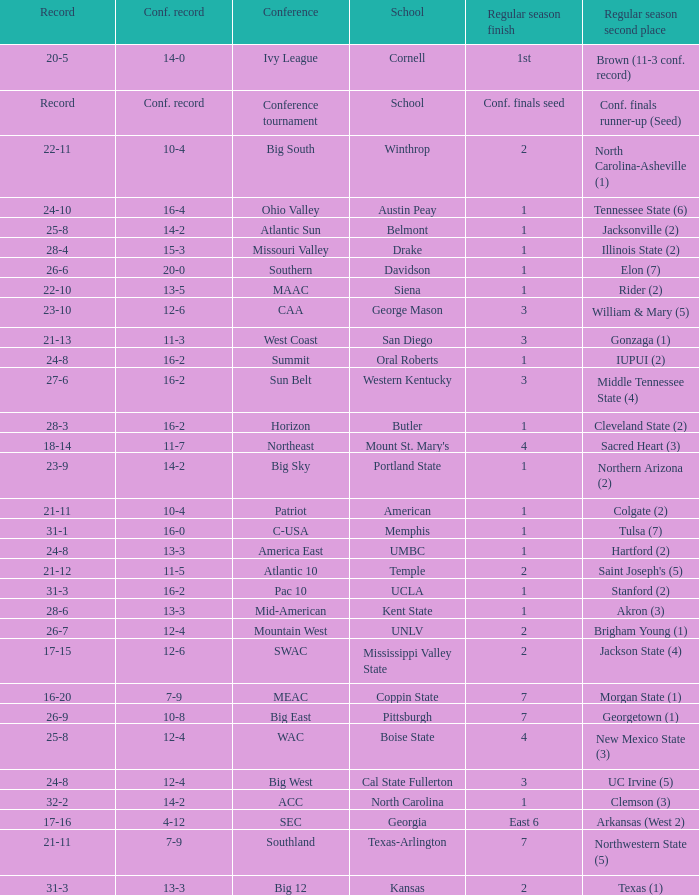What was the overall record of Oral Roberts college? 24-8. 